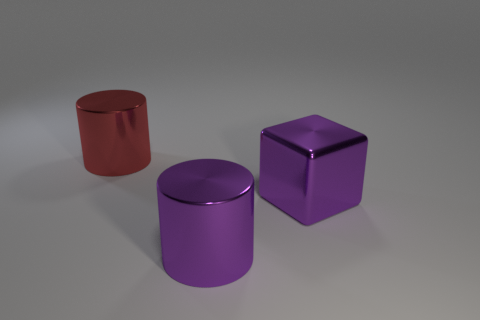Add 1 tiny yellow matte things. How many objects exist? 4 Subtract all cylinders. How many objects are left? 1 Subtract all green blocks. Subtract all big purple shiny blocks. How many objects are left? 2 Add 1 big objects. How many big objects are left? 4 Add 1 big red shiny things. How many big red shiny things exist? 2 Subtract 1 purple cubes. How many objects are left? 2 